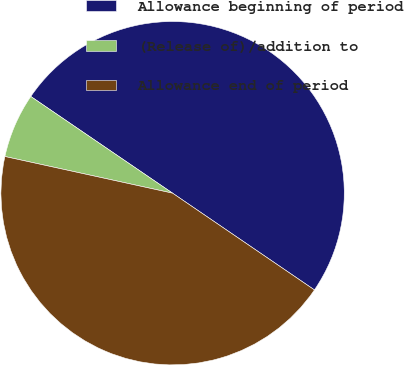<chart> <loc_0><loc_0><loc_500><loc_500><pie_chart><fcel>Allowance beginning of period<fcel>(Release of)/addition to<fcel>Allowance end of period<nl><fcel>50.0%<fcel>6.1%<fcel>43.9%<nl></chart> 